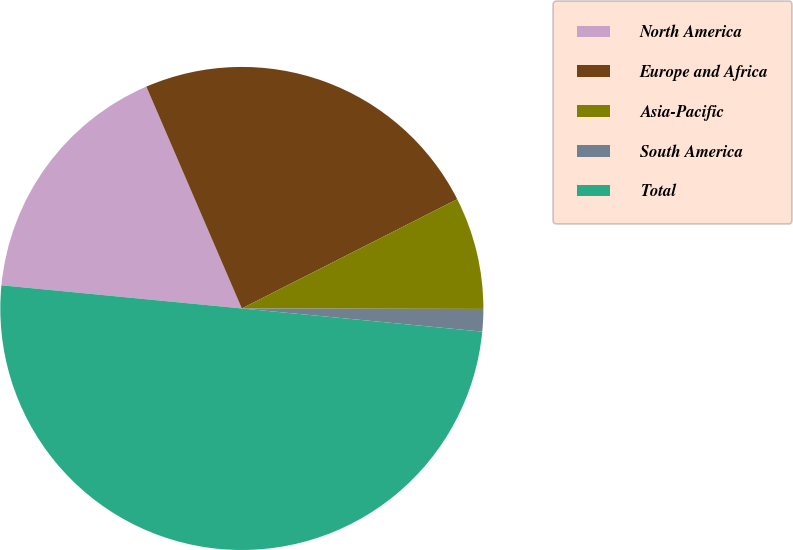Convert chart. <chart><loc_0><loc_0><loc_500><loc_500><pie_chart><fcel>North America<fcel>Europe and Africa<fcel>Asia-Pacific<fcel>South America<fcel>Total<nl><fcel>17.0%<fcel>24.0%<fcel>7.5%<fcel>1.5%<fcel>50.0%<nl></chart> 